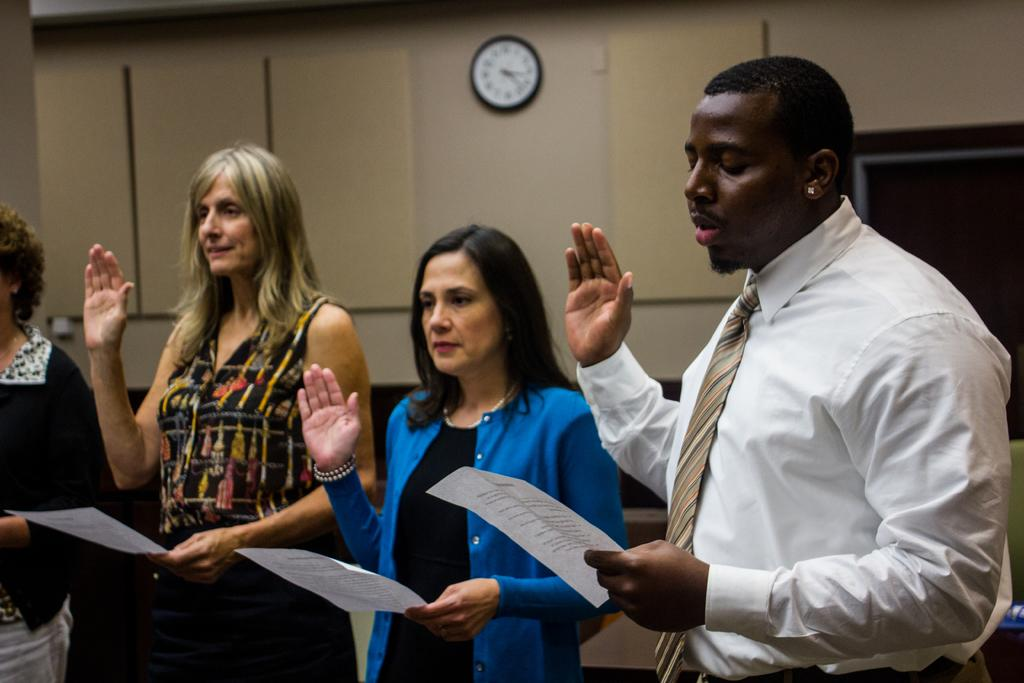What are the people in the image doing? The people in the image are standing in the center and holding papers in their hands. What can be seen in the background of the image? There is a wall in the background of the image. Is there anything on the wall in the image? Yes, there is a clock on the wall. Can you tell me how many bikes are parked near the people in the image? There are no bikes present in the image. What type of clam is being used as a paperweight on the papers held by the people? There are no clams present in the image, and the papers are not being held down by any objects. 